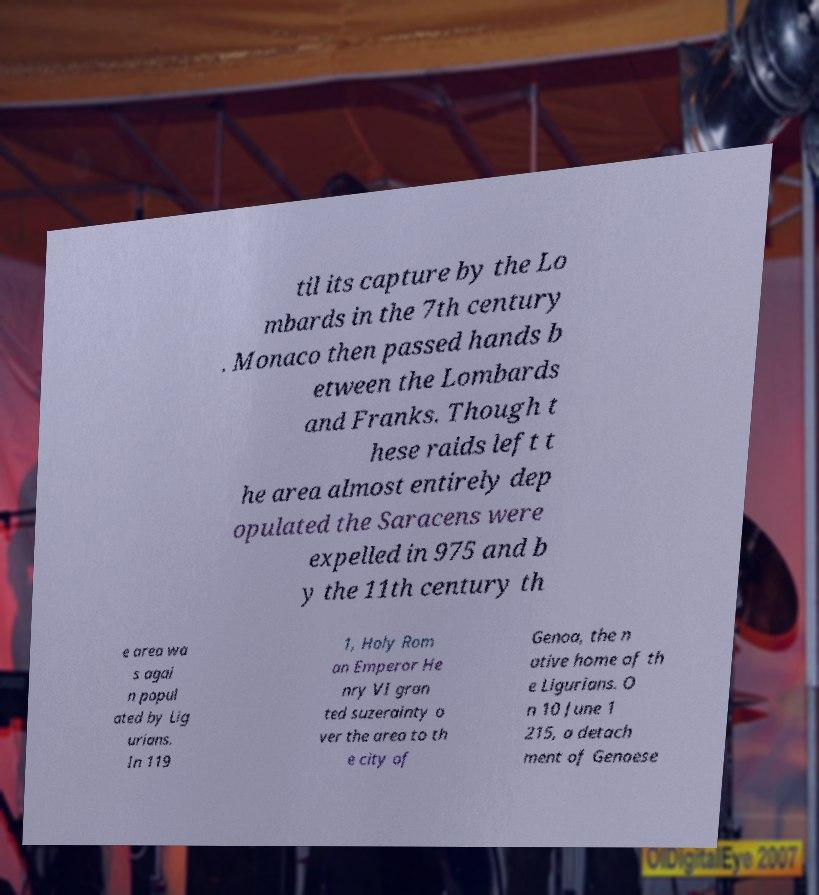For documentation purposes, I need the text within this image transcribed. Could you provide that? til its capture by the Lo mbards in the 7th century . Monaco then passed hands b etween the Lombards and Franks. Though t hese raids left t he area almost entirely dep opulated the Saracens were expelled in 975 and b y the 11th century th e area wa s agai n popul ated by Lig urians. In 119 1, Holy Rom an Emperor He nry VI gran ted suzerainty o ver the area to th e city of Genoa, the n ative home of th e Ligurians. O n 10 June 1 215, a detach ment of Genoese 